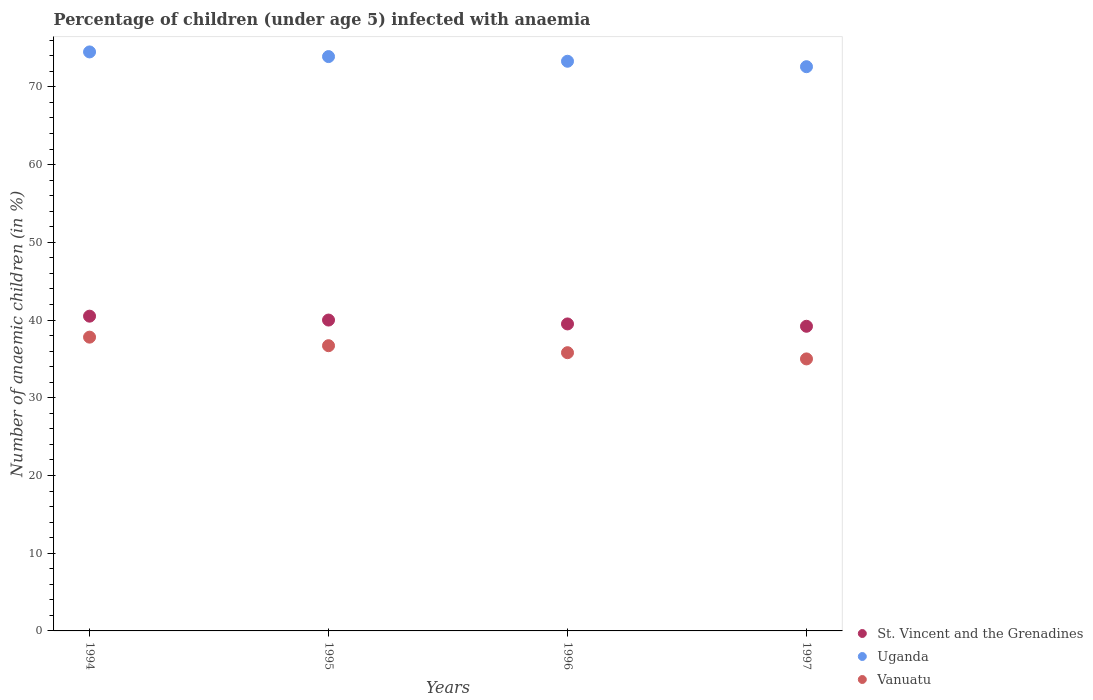Is the number of dotlines equal to the number of legend labels?
Your answer should be very brief. Yes. What is the percentage of children infected with anaemia in in St. Vincent and the Grenadines in 1997?
Ensure brevity in your answer.  39.2. Across all years, what is the maximum percentage of children infected with anaemia in in Vanuatu?
Offer a very short reply. 37.8. Across all years, what is the minimum percentage of children infected with anaemia in in Uganda?
Make the answer very short. 72.6. In which year was the percentage of children infected with anaemia in in Uganda maximum?
Your answer should be very brief. 1994. What is the total percentage of children infected with anaemia in in Vanuatu in the graph?
Give a very brief answer. 145.3. What is the difference between the percentage of children infected with anaemia in in St. Vincent and the Grenadines in 1996 and that in 1997?
Ensure brevity in your answer.  0.3. What is the average percentage of children infected with anaemia in in St. Vincent and the Grenadines per year?
Provide a short and direct response. 39.8. In the year 1997, what is the difference between the percentage of children infected with anaemia in in St. Vincent and the Grenadines and percentage of children infected with anaemia in in Uganda?
Offer a terse response. -33.4. What is the ratio of the percentage of children infected with anaemia in in Vanuatu in 1994 to that in 1997?
Keep it short and to the point. 1.08. What is the difference between the highest and the second highest percentage of children infected with anaemia in in Vanuatu?
Offer a terse response. 1.1. What is the difference between the highest and the lowest percentage of children infected with anaemia in in Vanuatu?
Provide a short and direct response. 2.8. Is the percentage of children infected with anaemia in in Vanuatu strictly greater than the percentage of children infected with anaemia in in Uganda over the years?
Provide a succinct answer. No. How many years are there in the graph?
Your response must be concise. 4. Are the values on the major ticks of Y-axis written in scientific E-notation?
Offer a terse response. No. How are the legend labels stacked?
Make the answer very short. Vertical. What is the title of the graph?
Make the answer very short. Percentage of children (under age 5) infected with anaemia. What is the label or title of the X-axis?
Make the answer very short. Years. What is the label or title of the Y-axis?
Your answer should be very brief. Number of anaemic children (in %). What is the Number of anaemic children (in %) in St. Vincent and the Grenadines in 1994?
Your answer should be very brief. 40.5. What is the Number of anaemic children (in %) in Uganda in 1994?
Make the answer very short. 74.5. What is the Number of anaemic children (in %) of Vanuatu in 1994?
Offer a terse response. 37.8. What is the Number of anaemic children (in %) in Uganda in 1995?
Your answer should be compact. 73.9. What is the Number of anaemic children (in %) in Vanuatu in 1995?
Make the answer very short. 36.7. What is the Number of anaemic children (in %) in St. Vincent and the Grenadines in 1996?
Give a very brief answer. 39.5. What is the Number of anaemic children (in %) of Uganda in 1996?
Offer a very short reply. 73.3. What is the Number of anaemic children (in %) in Vanuatu in 1996?
Provide a short and direct response. 35.8. What is the Number of anaemic children (in %) in St. Vincent and the Grenadines in 1997?
Make the answer very short. 39.2. What is the Number of anaemic children (in %) in Uganda in 1997?
Offer a very short reply. 72.6. Across all years, what is the maximum Number of anaemic children (in %) in St. Vincent and the Grenadines?
Keep it short and to the point. 40.5. Across all years, what is the maximum Number of anaemic children (in %) of Uganda?
Provide a short and direct response. 74.5. Across all years, what is the maximum Number of anaemic children (in %) in Vanuatu?
Ensure brevity in your answer.  37.8. Across all years, what is the minimum Number of anaemic children (in %) in St. Vincent and the Grenadines?
Make the answer very short. 39.2. Across all years, what is the minimum Number of anaemic children (in %) in Uganda?
Your answer should be very brief. 72.6. What is the total Number of anaemic children (in %) of St. Vincent and the Grenadines in the graph?
Provide a succinct answer. 159.2. What is the total Number of anaemic children (in %) of Uganda in the graph?
Offer a very short reply. 294.3. What is the total Number of anaemic children (in %) of Vanuatu in the graph?
Offer a terse response. 145.3. What is the difference between the Number of anaemic children (in %) in Uganda in 1994 and that in 1995?
Offer a very short reply. 0.6. What is the difference between the Number of anaemic children (in %) of Vanuatu in 1994 and that in 1995?
Provide a short and direct response. 1.1. What is the difference between the Number of anaemic children (in %) of St. Vincent and the Grenadines in 1994 and that in 1997?
Offer a terse response. 1.3. What is the difference between the Number of anaemic children (in %) of Vanuatu in 1994 and that in 1997?
Make the answer very short. 2.8. What is the difference between the Number of anaemic children (in %) of St. Vincent and the Grenadines in 1995 and that in 1997?
Ensure brevity in your answer.  0.8. What is the difference between the Number of anaemic children (in %) in Vanuatu in 1995 and that in 1997?
Give a very brief answer. 1.7. What is the difference between the Number of anaemic children (in %) in St. Vincent and the Grenadines in 1996 and that in 1997?
Give a very brief answer. 0.3. What is the difference between the Number of anaemic children (in %) of Uganda in 1996 and that in 1997?
Give a very brief answer. 0.7. What is the difference between the Number of anaemic children (in %) of Vanuatu in 1996 and that in 1997?
Offer a terse response. 0.8. What is the difference between the Number of anaemic children (in %) in St. Vincent and the Grenadines in 1994 and the Number of anaemic children (in %) in Uganda in 1995?
Provide a succinct answer. -33.4. What is the difference between the Number of anaemic children (in %) in St. Vincent and the Grenadines in 1994 and the Number of anaemic children (in %) in Vanuatu in 1995?
Ensure brevity in your answer.  3.8. What is the difference between the Number of anaemic children (in %) of Uganda in 1994 and the Number of anaemic children (in %) of Vanuatu in 1995?
Offer a very short reply. 37.8. What is the difference between the Number of anaemic children (in %) in St. Vincent and the Grenadines in 1994 and the Number of anaemic children (in %) in Uganda in 1996?
Your answer should be very brief. -32.8. What is the difference between the Number of anaemic children (in %) in Uganda in 1994 and the Number of anaemic children (in %) in Vanuatu in 1996?
Provide a short and direct response. 38.7. What is the difference between the Number of anaemic children (in %) in St. Vincent and the Grenadines in 1994 and the Number of anaemic children (in %) in Uganda in 1997?
Make the answer very short. -32.1. What is the difference between the Number of anaemic children (in %) in St. Vincent and the Grenadines in 1994 and the Number of anaemic children (in %) in Vanuatu in 1997?
Provide a short and direct response. 5.5. What is the difference between the Number of anaemic children (in %) of Uganda in 1994 and the Number of anaemic children (in %) of Vanuatu in 1997?
Offer a very short reply. 39.5. What is the difference between the Number of anaemic children (in %) of St. Vincent and the Grenadines in 1995 and the Number of anaemic children (in %) of Uganda in 1996?
Offer a very short reply. -33.3. What is the difference between the Number of anaemic children (in %) in St. Vincent and the Grenadines in 1995 and the Number of anaemic children (in %) in Vanuatu in 1996?
Make the answer very short. 4.2. What is the difference between the Number of anaemic children (in %) in Uganda in 1995 and the Number of anaemic children (in %) in Vanuatu in 1996?
Offer a very short reply. 38.1. What is the difference between the Number of anaemic children (in %) in St. Vincent and the Grenadines in 1995 and the Number of anaemic children (in %) in Uganda in 1997?
Make the answer very short. -32.6. What is the difference between the Number of anaemic children (in %) in St. Vincent and the Grenadines in 1995 and the Number of anaemic children (in %) in Vanuatu in 1997?
Your answer should be very brief. 5. What is the difference between the Number of anaemic children (in %) of Uganda in 1995 and the Number of anaemic children (in %) of Vanuatu in 1997?
Offer a terse response. 38.9. What is the difference between the Number of anaemic children (in %) in St. Vincent and the Grenadines in 1996 and the Number of anaemic children (in %) in Uganda in 1997?
Make the answer very short. -33.1. What is the difference between the Number of anaemic children (in %) of Uganda in 1996 and the Number of anaemic children (in %) of Vanuatu in 1997?
Ensure brevity in your answer.  38.3. What is the average Number of anaemic children (in %) of St. Vincent and the Grenadines per year?
Make the answer very short. 39.8. What is the average Number of anaemic children (in %) in Uganda per year?
Provide a succinct answer. 73.58. What is the average Number of anaemic children (in %) in Vanuatu per year?
Your response must be concise. 36.33. In the year 1994, what is the difference between the Number of anaemic children (in %) in St. Vincent and the Grenadines and Number of anaemic children (in %) in Uganda?
Give a very brief answer. -34. In the year 1994, what is the difference between the Number of anaemic children (in %) in Uganda and Number of anaemic children (in %) in Vanuatu?
Offer a very short reply. 36.7. In the year 1995, what is the difference between the Number of anaemic children (in %) in St. Vincent and the Grenadines and Number of anaemic children (in %) in Uganda?
Your response must be concise. -33.9. In the year 1995, what is the difference between the Number of anaemic children (in %) in Uganda and Number of anaemic children (in %) in Vanuatu?
Ensure brevity in your answer.  37.2. In the year 1996, what is the difference between the Number of anaemic children (in %) in St. Vincent and the Grenadines and Number of anaemic children (in %) in Uganda?
Provide a short and direct response. -33.8. In the year 1996, what is the difference between the Number of anaemic children (in %) of Uganda and Number of anaemic children (in %) of Vanuatu?
Make the answer very short. 37.5. In the year 1997, what is the difference between the Number of anaemic children (in %) in St. Vincent and the Grenadines and Number of anaemic children (in %) in Uganda?
Keep it short and to the point. -33.4. In the year 1997, what is the difference between the Number of anaemic children (in %) of St. Vincent and the Grenadines and Number of anaemic children (in %) of Vanuatu?
Offer a very short reply. 4.2. In the year 1997, what is the difference between the Number of anaemic children (in %) of Uganda and Number of anaemic children (in %) of Vanuatu?
Provide a succinct answer. 37.6. What is the ratio of the Number of anaemic children (in %) of St. Vincent and the Grenadines in 1994 to that in 1995?
Give a very brief answer. 1.01. What is the ratio of the Number of anaemic children (in %) in Vanuatu in 1994 to that in 1995?
Your answer should be very brief. 1.03. What is the ratio of the Number of anaemic children (in %) in St. Vincent and the Grenadines in 1994 to that in 1996?
Provide a short and direct response. 1.03. What is the ratio of the Number of anaemic children (in %) in Uganda in 1994 to that in 1996?
Offer a terse response. 1.02. What is the ratio of the Number of anaemic children (in %) of Vanuatu in 1994 to that in 1996?
Provide a short and direct response. 1.06. What is the ratio of the Number of anaemic children (in %) of St. Vincent and the Grenadines in 1994 to that in 1997?
Your answer should be compact. 1.03. What is the ratio of the Number of anaemic children (in %) of Uganda in 1994 to that in 1997?
Make the answer very short. 1.03. What is the ratio of the Number of anaemic children (in %) of St. Vincent and the Grenadines in 1995 to that in 1996?
Ensure brevity in your answer.  1.01. What is the ratio of the Number of anaemic children (in %) in Uganda in 1995 to that in 1996?
Make the answer very short. 1.01. What is the ratio of the Number of anaemic children (in %) of Vanuatu in 1995 to that in 1996?
Your answer should be compact. 1.03. What is the ratio of the Number of anaemic children (in %) in St. Vincent and the Grenadines in 1995 to that in 1997?
Provide a succinct answer. 1.02. What is the ratio of the Number of anaemic children (in %) of Uganda in 1995 to that in 1997?
Your response must be concise. 1.02. What is the ratio of the Number of anaemic children (in %) of Vanuatu in 1995 to that in 1997?
Provide a short and direct response. 1.05. What is the ratio of the Number of anaemic children (in %) of St. Vincent and the Grenadines in 1996 to that in 1997?
Provide a short and direct response. 1.01. What is the ratio of the Number of anaemic children (in %) in Uganda in 1996 to that in 1997?
Provide a short and direct response. 1.01. What is the ratio of the Number of anaemic children (in %) of Vanuatu in 1996 to that in 1997?
Give a very brief answer. 1.02. 